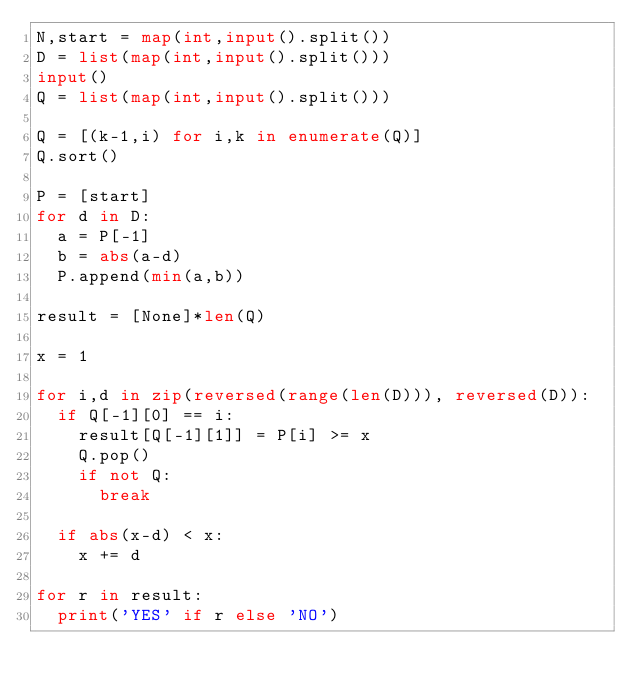<code> <loc_0><loc_0><loc_500><loc_500><_Python_>N,start = map(int,input().split())
D = list(map(int,input().split()))
input()
Q = list(map(int,input().split()))

Q = [(k-1,i) for i,k in enumerate(Q)]
Q.sort()

P = [start]
for d in D:
  a = P[-1]
  b = abs(a-d)
  P.append(min(a,b))

result = [None]*len(Q)

x = 1

for i,d in zip(reversed(range(len(D))), reversed(D)):
  if Q[-1][0] == i:
    result[Q[-1][1]] = P[i] >= x
    Q.pop()
    if not Q:
      break

  if abs(x-d) < x:
    x += d

for r in result:
  print('YES' if r else 'NO')</code> 